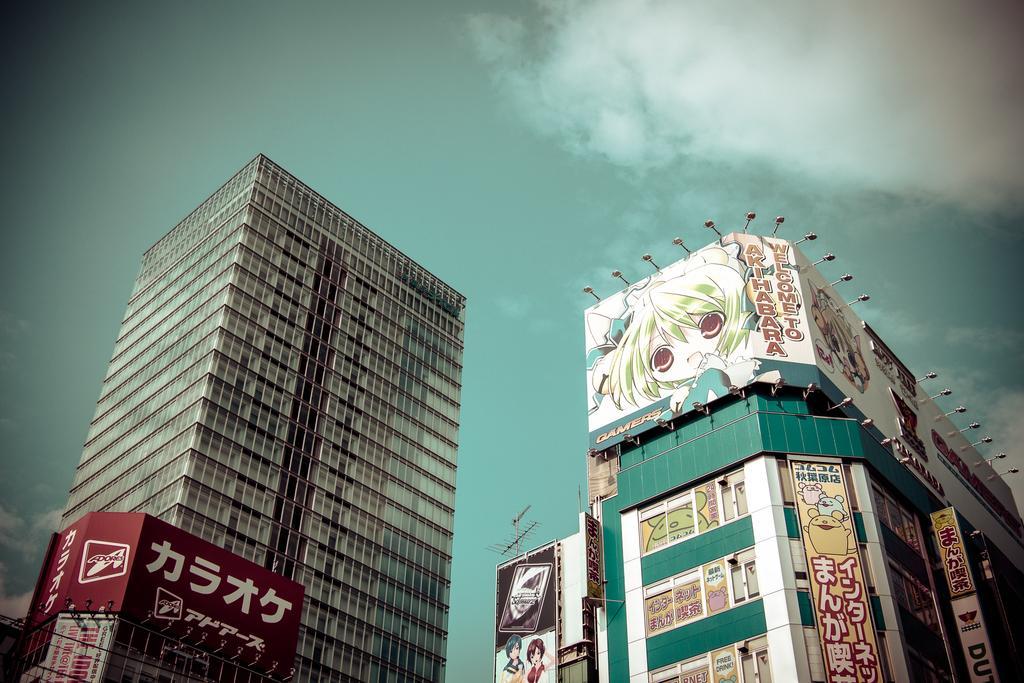In one or two sentences, can you explain what this image depicts? In this picture I can see the buildings. On the right I can see the posters, banners and advertising board. Above the board I can see the lights. At the top I can see the sky and clouds. 